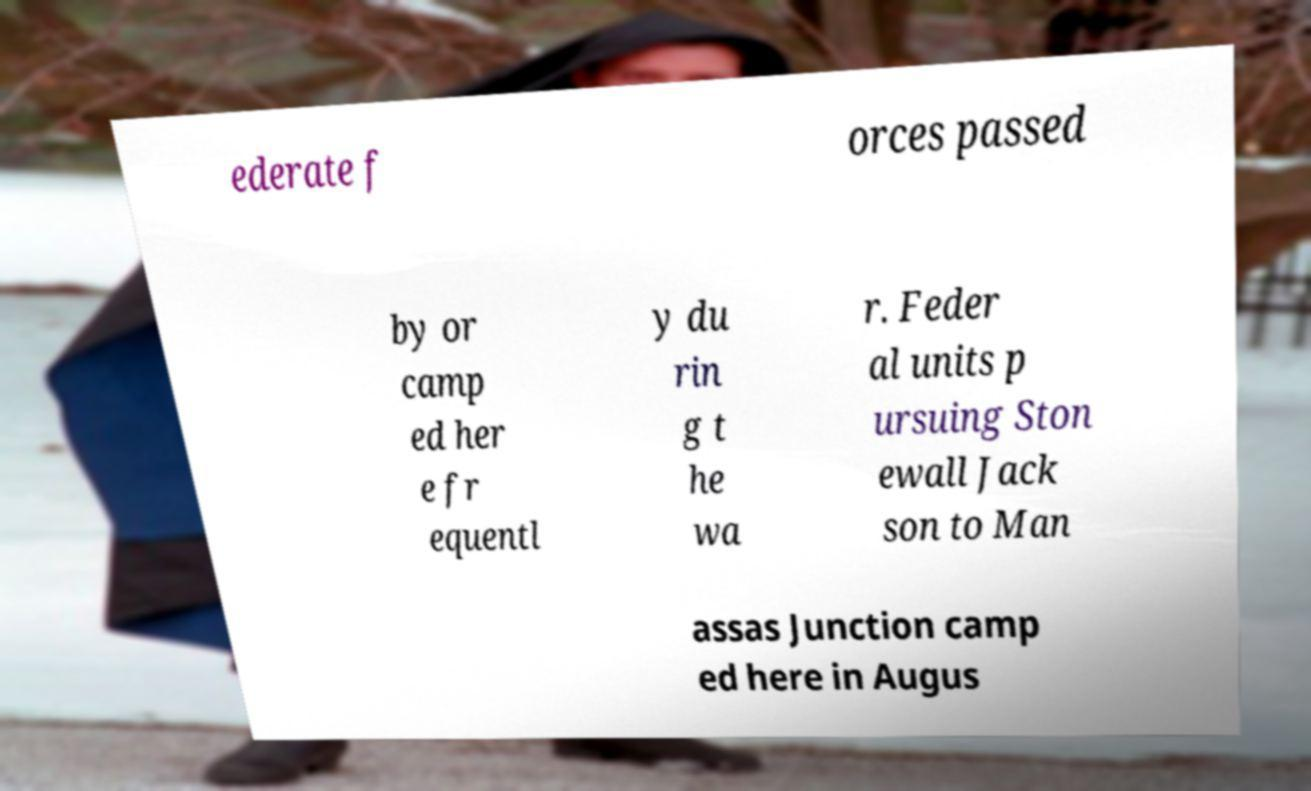There's text embedded in this image that I need extracted. Can you transcribe it verbatim? ederate f orces passed by or camp ed her e fr equentl y du rin g t he wa r. Feder al units p ursuing Ston ewall Jack son to Man assas Junction camp ed here in Augus 